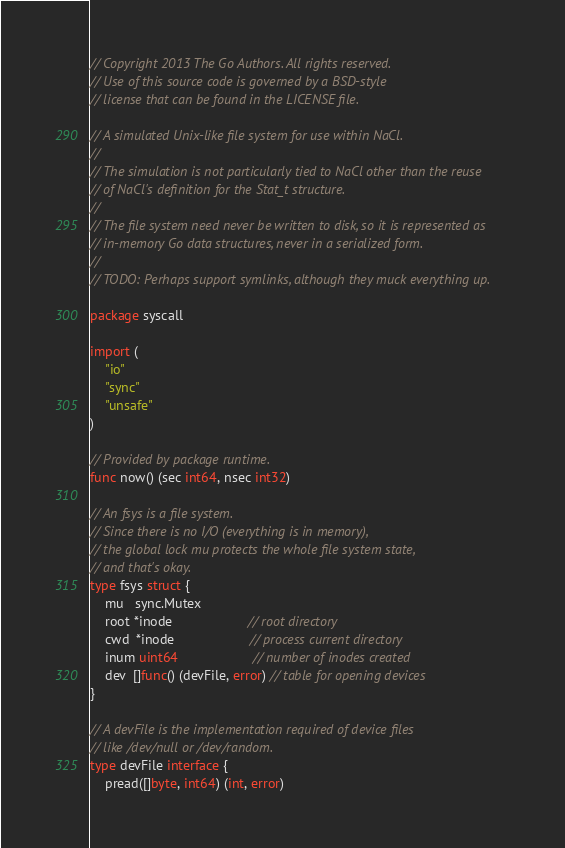Convert code to text. <code><loc_0><loc_0><loc_500><loc_500><_Go_>// Copyright 2013 The Go Authors. All rights reserved.
// Use of this source code is governed by a BSD-style
// license that can be found in the LICENSE file.

// A simulated Unix-like file system for use within NaCl.
//
// The simulation is not particularly tied to NaCl other than the reuse
// of NaCl's definition for the Stat_t structure.
//
// The file system need never be written to disk, so it is represented as
// in-memory Go data structures, never in a serialized form.
//
// TODO: Perhaps support symlinks, although they muck everything up.

package syscall

import (
	"io"
	"sync"
	"unsafe"
)

// Provided by package runtime.
func now() (sec int64, nsec int32)

// An fsys is a file system.
// Since there is no I/O (everything is in memory),
// the global lock mu protects the whole file system state,
// and that's okay.
type fsys struct {
	mu   sync.Mutex
	root *inode                    // root directory
	cwd  *inode                    // process current directory
	inum uint64                    // number of inodes created
	dev  []func() (devFile, error) // table for opening devices
}

// A devFile is the implementation required of device files
// like /dev/null or /dev/random.
type devFile interface {
	pread([]byte, int64) (int, error)</code> 